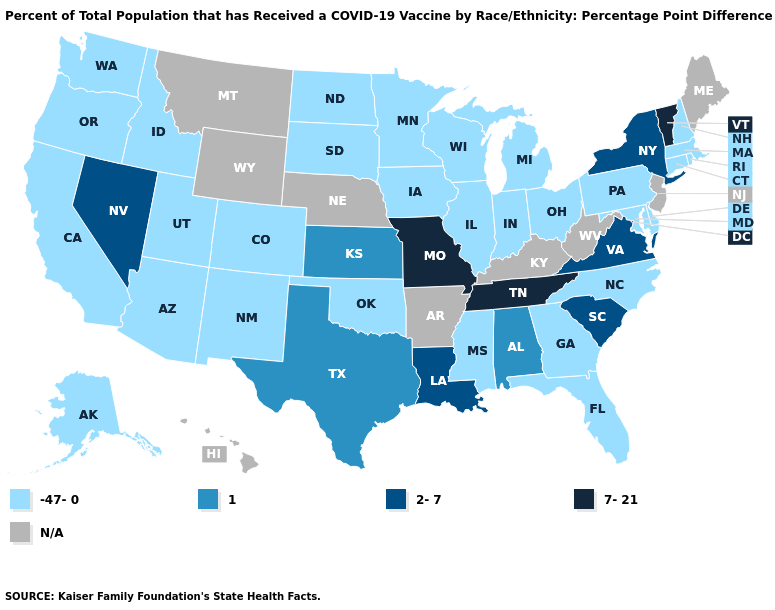How many symbols are there in the legend?
Answer briefly. 5. Which states have the lowest value in the USA?
Short answer required. Alaska, Arizona, California, Colorado, Connecticut, Delaware, Florida, Georgia, Idaho, Illinois, Indiana, Iowa, Maryland, Massachusetts, Michigan, Minnesota, Mississippi, New Hampshire, New Mexico, North Carolina, North Dakota, Ohio, Oklahoma, Oregon, Pennsylvania, Rhode Island, South Dakota, Utah, Washington, Wisconsin. What is the lowest value in states that border Montana?
Quick response, please. -47-0. What is the value of Louisiana?
Quick response, please. 2-7. Does the map have missing data?
Quick response, please. Yes. What is the highest value in the USA?
Quick response, please. 7-21. Does Oklahoma have the lowest value in the USA?
Be succinct. Yes. Among the states that border Tennessee , does Alabama have the lowest value?
Answer briefly. No. Name the states that have a value in the range -47-0?
Be succinct. Alaska, Arizona, California, Colorado, Connecticut, Delaware, Florida, Georgia, Idaho, Illinois, Indiana, Iowa, Maryland, Massachusetts, Michigan, Minnesota, Mississippi, New Hampshire, New Mexico, North Carolina, North Dakota, Ohio, Oklahoma, Oregon, Pennsylvania, Rhode Island, South Dakota, Utah, Washington, Wisconsin. Name the states that have a value in the range N/A?
Answer briefly. Arkansas, Hawaii, Kentucky, Maine, Montana, Nebraska, New Jersey, West Virginia, Wyoming. What is the value of Kansas?
Concise answer only. 1. Does the map have missing data?
Keep it brief. Yes. What is the value of Indiana?
Answer briefly. -47-0. What is the highest value in the USA?
Concise answer only. 7-21. What is the value of Oklahoma?
Answer briefly. -47-0. 